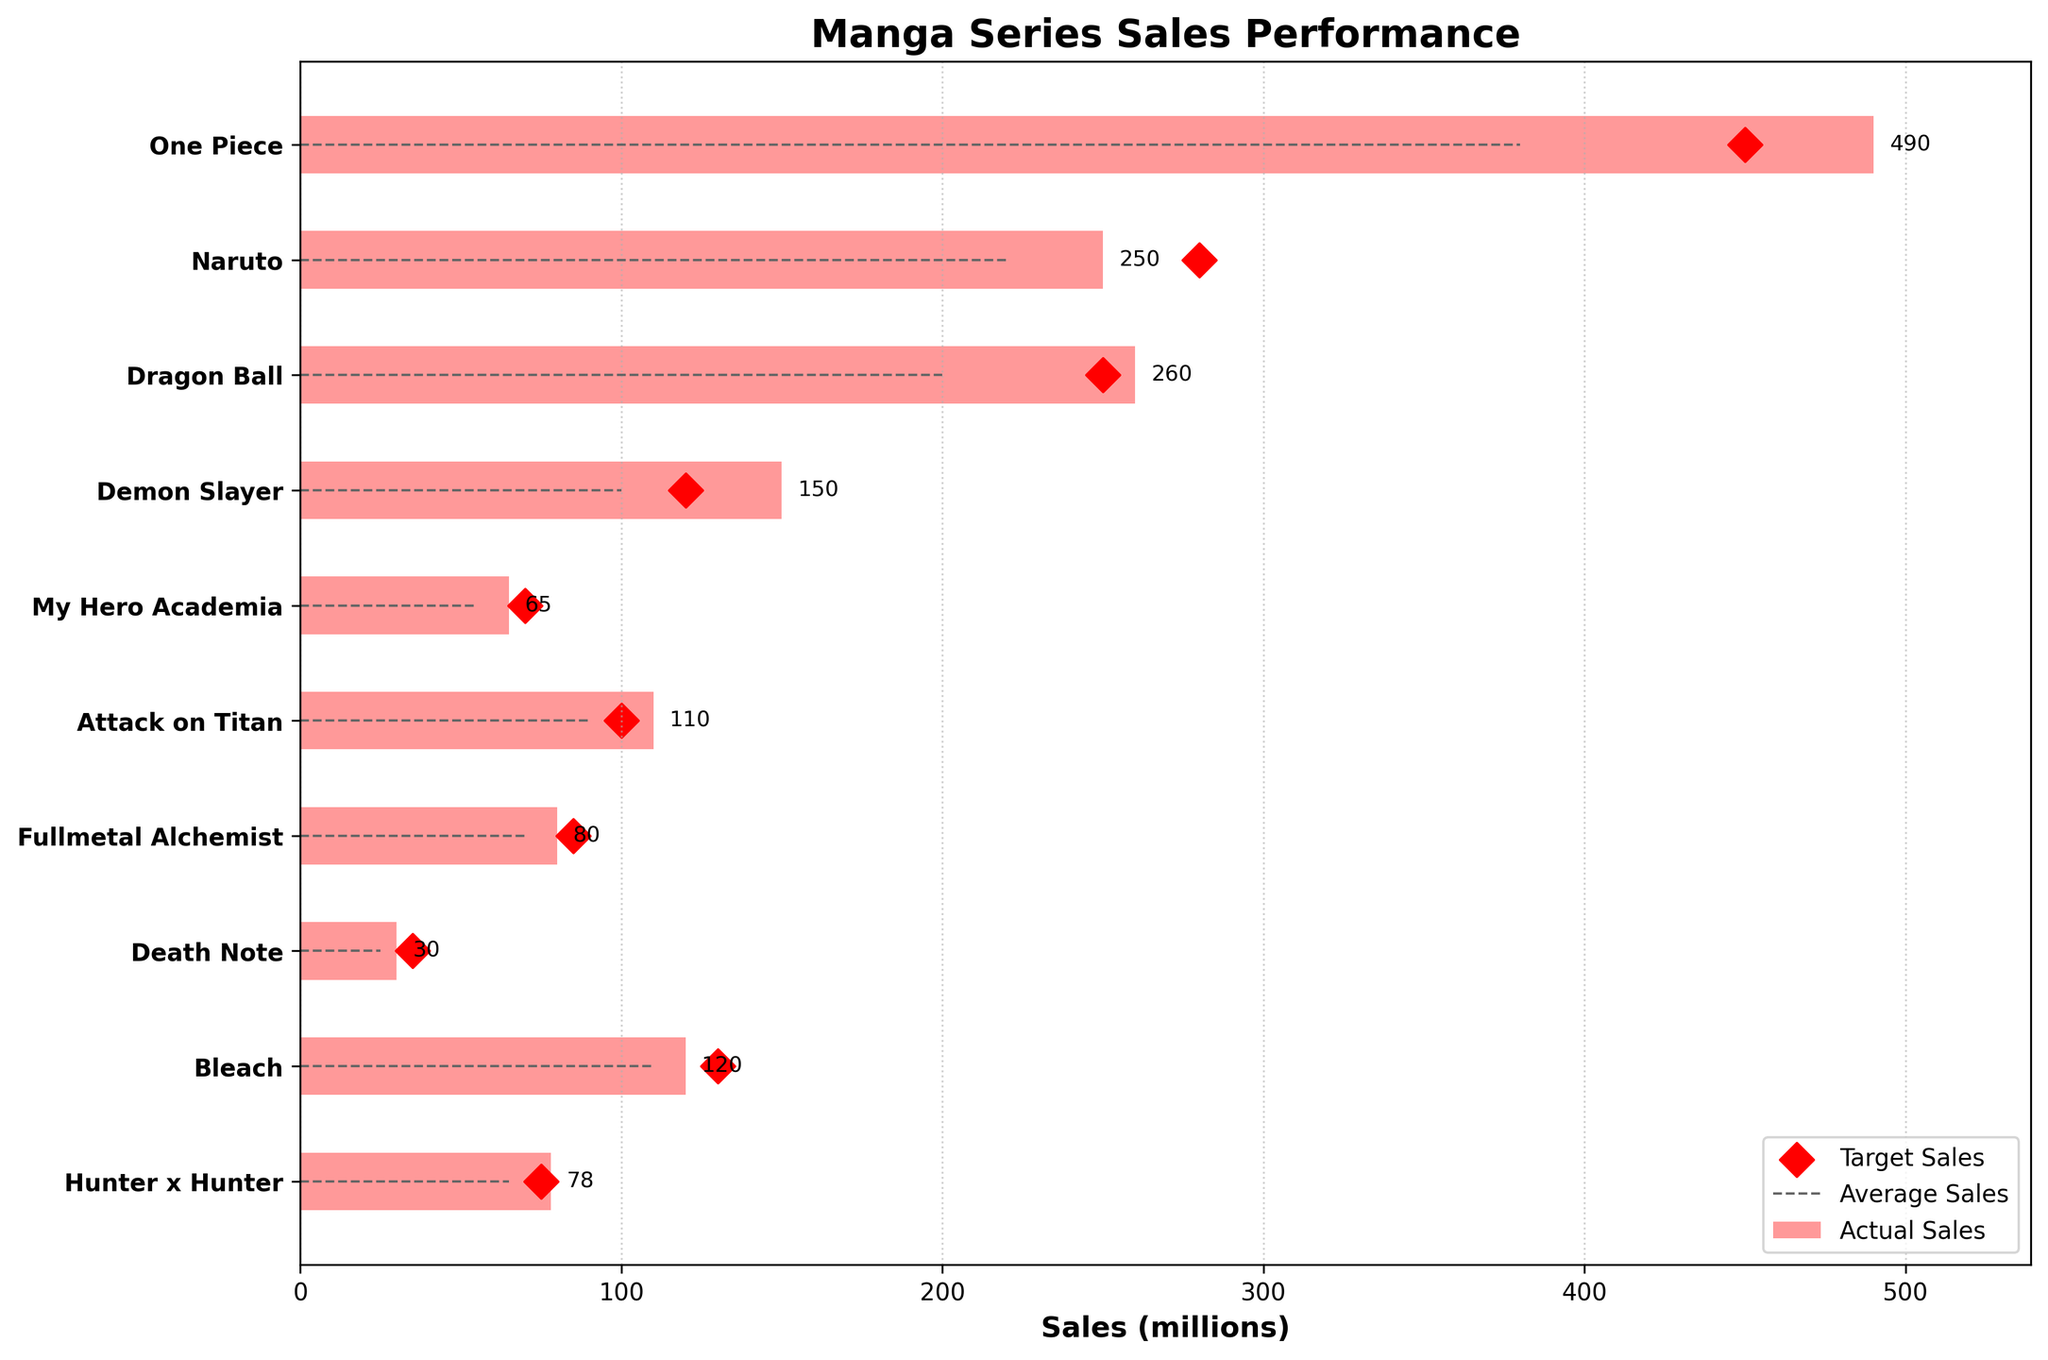What's the title of the plot? The title is displayed at the top of the plot, indicating the main topic of the figure.
Answer: Manga Series Sales Performance Which manga series has the highest actual sales? To find the series with the highest actual sales, look for the largest bar in the plot indicating actual sales.
Answer: One Piece What is the target sales value for "Naruto"? Look for the diamond marker on the horizontal line corresponding to "Naruto" and read the value next to it.
Answer: 280 million How many series have exceeded their target sales? Compare the actual sales bars with the target sales markers for each series. Count the series where the bar exceeds the marker.
Answer: Five series Which series had the least actual sales, and what was the value? Identify the smallest bar in the plot and refer to the label to determine the series and its corresponding value.
Answer: Death Note, 30 million Is the average sales value of "Attack on Titan" higher or lower than its target sales? Compare the line (average sales) and the diamond marker (target sales) for "Attack on Titan."
Answer: Lower What is the difference in actual sales between "Bleach" and "Death Note"? Subtract the actual sales of "Death Note" from "Bleach." Actual sales for Bleach: 120 million, for Death Note: 30 million. 120 - 30 = 90.
Answer: 90 million How does "My Hero Academia" fare in actual sales compared to its target sales? Compare the length of the bar for actual sales with the position of the diamond marker for target sales in "My Hero Academia."
Answer: Lower What is the average actual sales value of the top three best-selling series? Identify the top three series with the highest actual sales: One Piece (490), Dragon Ball (260), and Naruto (250). Calculate the average: (490 + 260 + 250) / 3 = 333.33 million.
Answer: 333.33 million Is the target sales of "Fullmetal Alchemist" higher than the average sales of "Hunter x Hunter"? Compare the target sales marker value of "Fullmetal Alchemist" with the line representing the average sales of "Hunter x Hunter."
Answer: Yes 